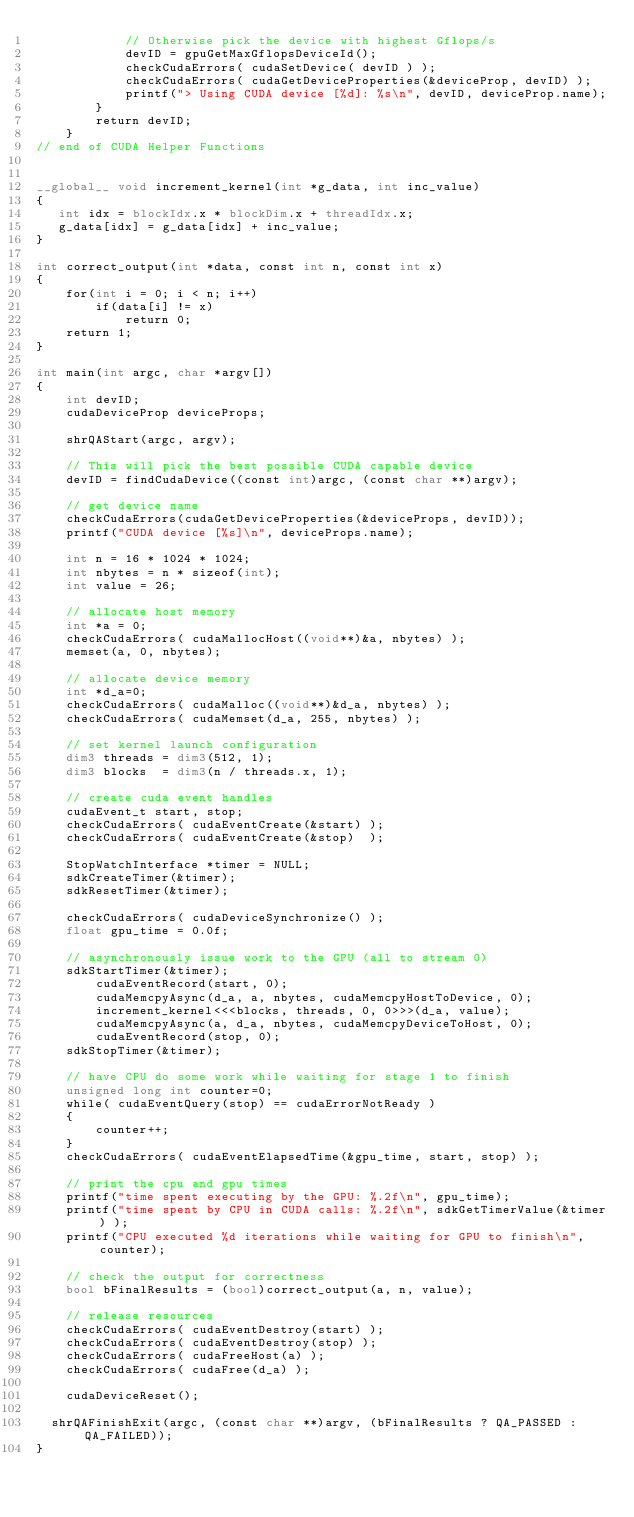<code> <loc_0><loc_0><loc_500><loc_500><_Cuda_>            // Otherwise pick the device with highest Gflops/s
            devID = gpuGetMaxGflopsDeviceId();
            checkCudaErrors( cudaSetDevice( devID ) );
            checkCudaErrors( cudaGetDeviceProperties(&deviceProp, devID) );
            printf("> Using CUDA device [%d]: %s\n", devID, deviceProp.name);
        }
        return devID;
    }
// end of CUDA Helper Functions


__global__ void increment_kernel(int *g_data, int inc_value)
{ 
   int idx = blockIdx.x * blockDim.x + threadIdx.x;
   g_data[idx] = g_data[idx] + inc_value;
}

int correct_output(int *data, const int n, const int x)
{
    for(int i = 0; i < n; i++)
        if(data[i] != x)
            return 0;
    return 1;
}

int main(int argc, char *argv[])
{
    int devID;
    cudaDeviceProp deviceProps;

    shrQAStart(argc, argv);

    // This will pick the best possible CUDA capable device
    devID = findCudaDevice((const int)argc, (const char **)argv);

    // get device name 
    checkCudaErrors(cudaGetDeviceProperties(&deviceProps, devID));
    printf("CUDA device [%s]\n", deviceProps.name);

    int n = 16 * 1024 * 1024;
    int nbytes = n * sizeof(int);
    int value = 26;

    // allocate host memory
    int *a = 0;
    checkCudaErrors( cudaMallocHost((void**)&a, nbytes) );
    memset(a, 0, nbytes);

    // allocate device memory
    int *d_a=0;
    checkCudaErrors( cudaMalloc((void**)&d_a, nbytes) );
    checkCudaErrors( cudaMemset(d_a, 255, nbytes) );

    // set kernel launch configuration
    dim3 threads = dim3(512, 1);
    dim3 blocks  = dim3(n / threads.x, 1);

    // create cuda event handles
    cudaEvent_t start, stop;
    checkCudaErrors( cudaEventCreate(&start) );
    checkCudaErrors( cudaEventCreate(&stop)  );
    
    StopWatchInterface *timer = NULL;
    sdkCreateTimer(&timer);
    sdkResetTimer(&timer);

    checkCudaErrors( cudaDeviceSynchronize() );
    float gpu_time = 0.0f;

    // asynchronously issue work to the GPU (all to stream 0)
    sdkStartTimer(&timer);
        cudaEventRecord(start, 0);
        cudaMemcpyAsync(d_a, a, nbytes, cudaMemcpyHostToDevice, 0);
        increment_kernel<<<blocks, threads, 0, 0>>>(d_a, value);
        cudaMemcpyAsync(a, d_a, nbytes, cudaMemcpyDeviceToHost, 0);
        cudaEventRecord(stop, 0);
    sdkStopTimer(&timer);

    // have CPU do some work while waiting for stage 1 to finish
    unsigned long int counter=0;
    while( cudaEventQuery(stop) == cudaErrorNotReady )
    {
        counter++;
    }
    checkCudaErrors( cudaEventElapsedTime(&gpu_time, start, stop) );

    // print the cpu and gpu times
    printf("time spent executing by the GPU: %.2f\n", gpu_time);
    printf("time spent by CPU in CUDA calls: %.2f\n", sdkGetTimerValue(&timer) );
    printf("CPU executed %d iterations while waiting for GPU to finish\n", counter);

    // check the output for correctness
    bool bFinalResults = (bool)correct_output(a, n, value);
	
    // release resources
    checkCudaErrors( cudaEventDestroy(start) );
    checkCudaErrors( cudaEventDestroy(stop) );
    checkCudaErrors( cudaFreeHost(a) );
    checkCudaErrors( cudaFree(d_a) );

    cudaDeviceReset();

	shrQAFinishExit(argc, (const char **)argv, (bFinalResults ? QA_PASSED : QA_FAILED));
}
</code> 